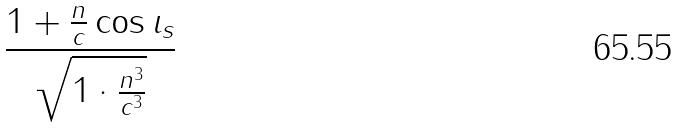Convert formula to latex. <formula><loc_0><loc_0><loc_500><loc_500>\frac { 1 + \frac { n } { c } \cos \iota _ { s } } { \sqrt { 1 \cdot \frac { n ^ { 3 } } { c ^ { 3 } } } }</formula> 